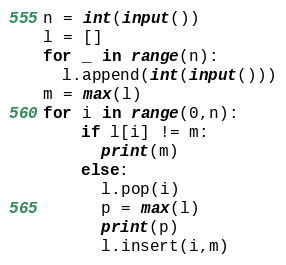<code> <loc_0><loc_0><loc_500><loc_500><_Python_>n = int(input())
l = []
for _ in range(n):
  l.append(int(input()))
m = max(l)
for i in range(0,n):
    if l[i] != m:
      print(m)
    else:
      l.pop(i)
      p = max(l)
      print(p)
      l.insert(i,m)</code> 